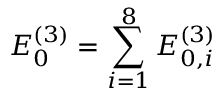Convert formula to latex. <formula><loc_0><loc_0><loc_500><loc_500>E _ { 0 } ^ { ( 3 ) } = \sum _ { i = 1 } ^ { 8 } E _ { 0 , i } ^ { ( 3 ) }</formula> 